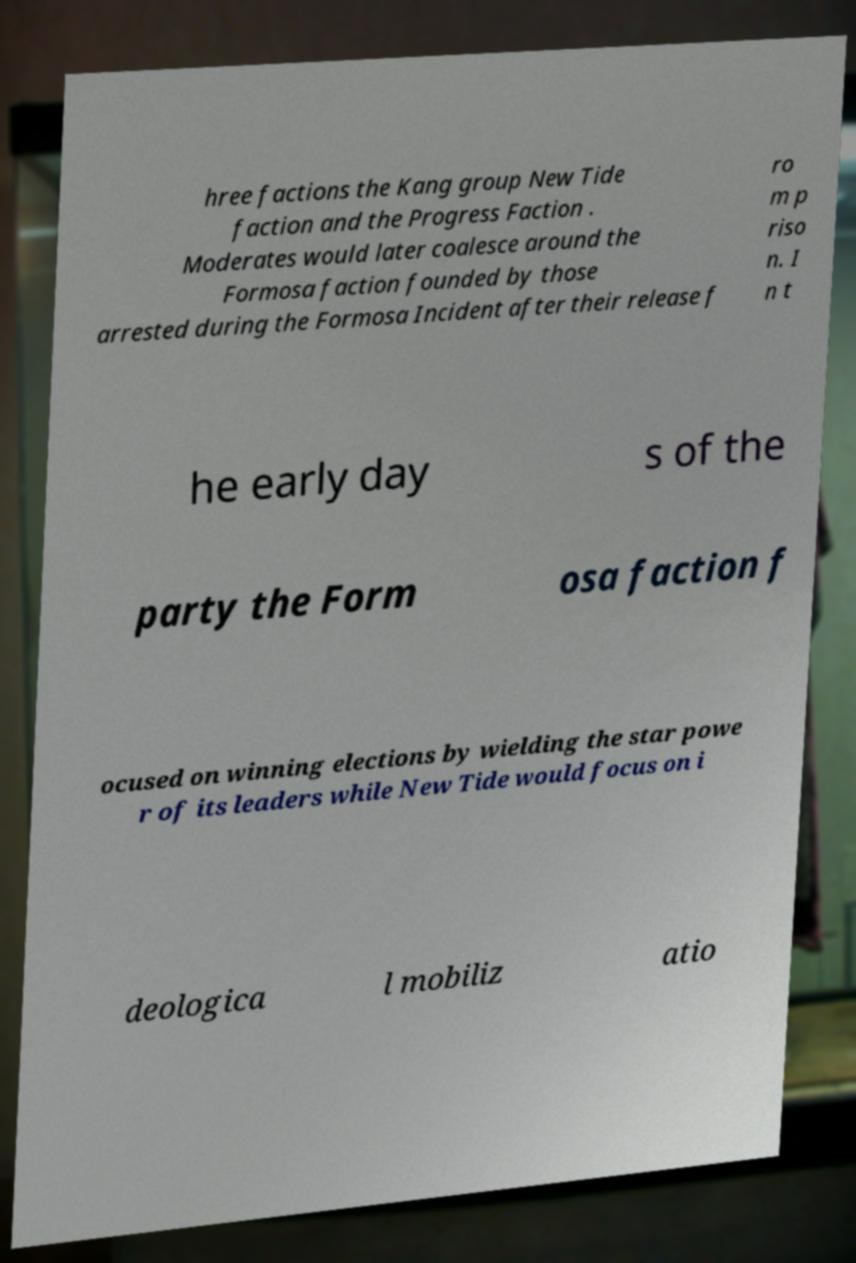Can you accurately transcribe the text from the provided image for me? hree factions the Kang group New Tide faction and the Progress Faction . Moderates would later coalesce around the Formosa faction founded by those arrested during the Formosa Incident after their release f ro m p riso n. I n t he early day s of the party the Form osa faction f ocused on winning elections by wielding the star powe r of its leaders while New Tide would focus on i deologica l mobiliz atio 